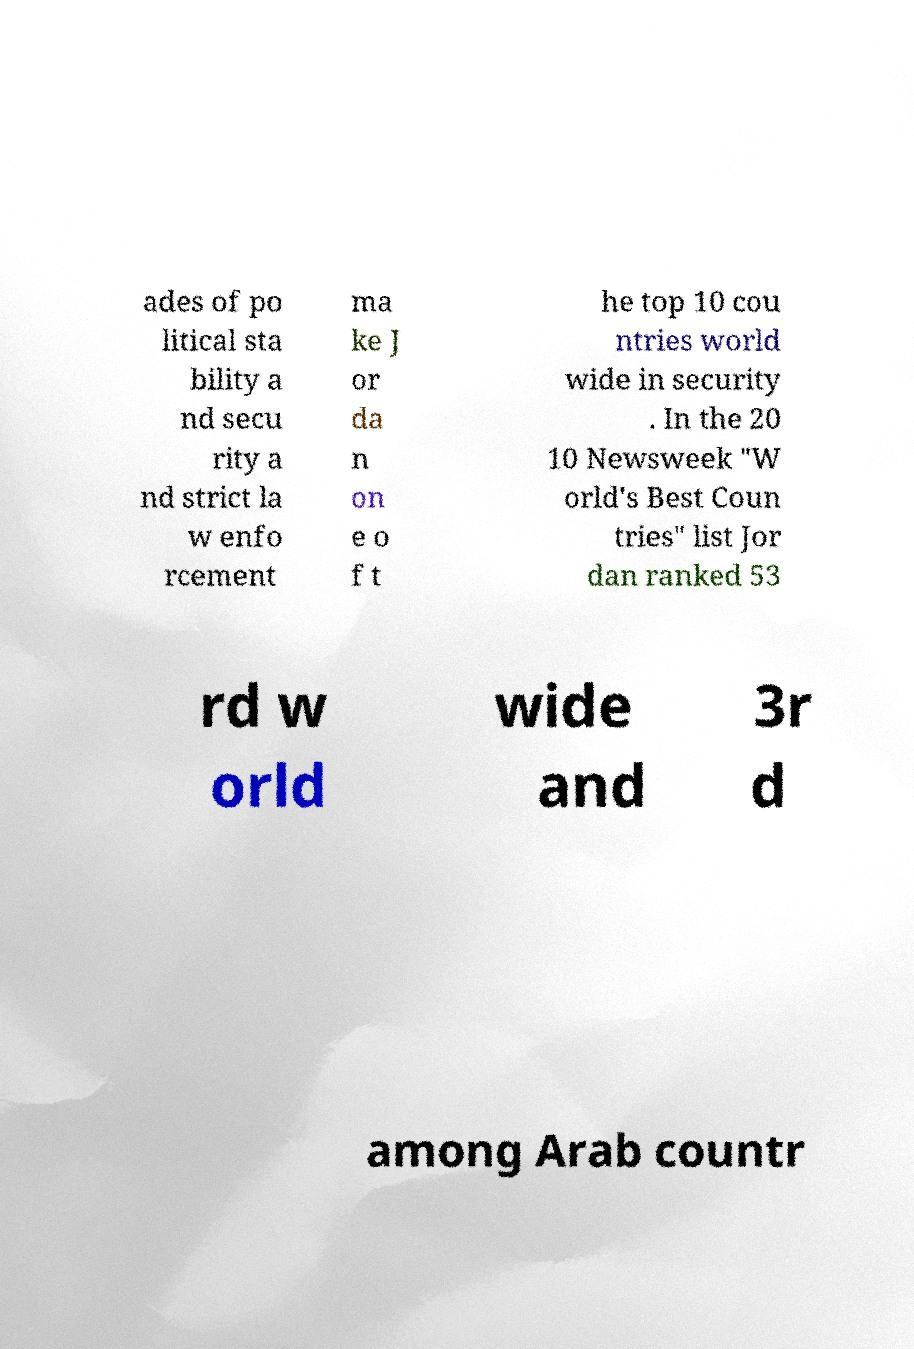Can you read and provide the text displayed in the image?This photo seems to have some interesting text. Can you extract and type it out for me? ades of po litical sta bility a nd secu rity a nd strict la w enfo rcement ma ke J or da n on e o f t he top 10 cou ntries world wide in security . In the 20 10 Newsweek "W orld's Best Coun tries" list Jor dan ranked 53 rd w orld wide and 3r d among Arab countr 